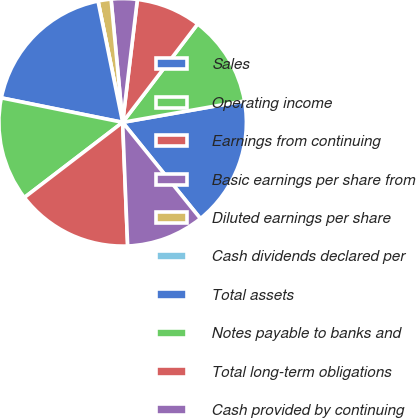Convert chart to OTSL. <chart><loc_0><loc_0><loc_500><loc_500><pie_chart><fcel>Sales<fcel>Operating income<fcel>Earnings from continuing<fcel>Basic earnings per share from<fcel>Diluted earnings per share<fcel>Cash dividends declared per<fcel>Total assets<fcel>Notes payable to banks and<fcel>Total long-term obligations<fcel>Cash provided by continuing<nl><fcel>16.95%<fcel>11.86%<fcel>8.47%<fcel>3.39%<fcel>1.7%<fcel>0.0%<fcel>18.64%<fcel>13.56%<fcel>15.25%<fcel>10.17%<nl></chart> 